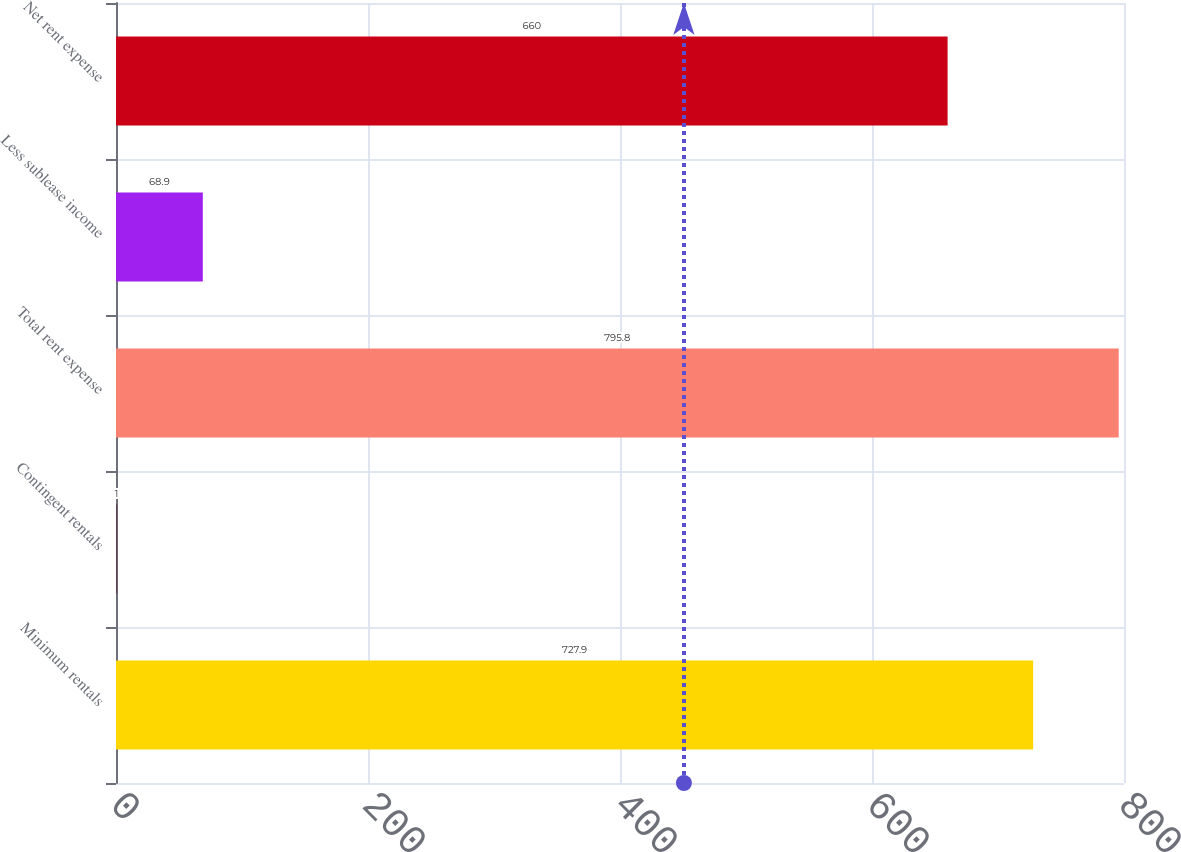<chart> <loc_0><loc_0><loc_500><loc_500><bar_chart><fcel>Minimum rentals<fcel>Contingent rentals<fcel>Total rent expense<fcel>Less sublease income<fcel>Net rent expense<nl><fcel>727.9<fcel>1<fcel>795.8<fcel>68.9<fcel>660<nl></chart> 